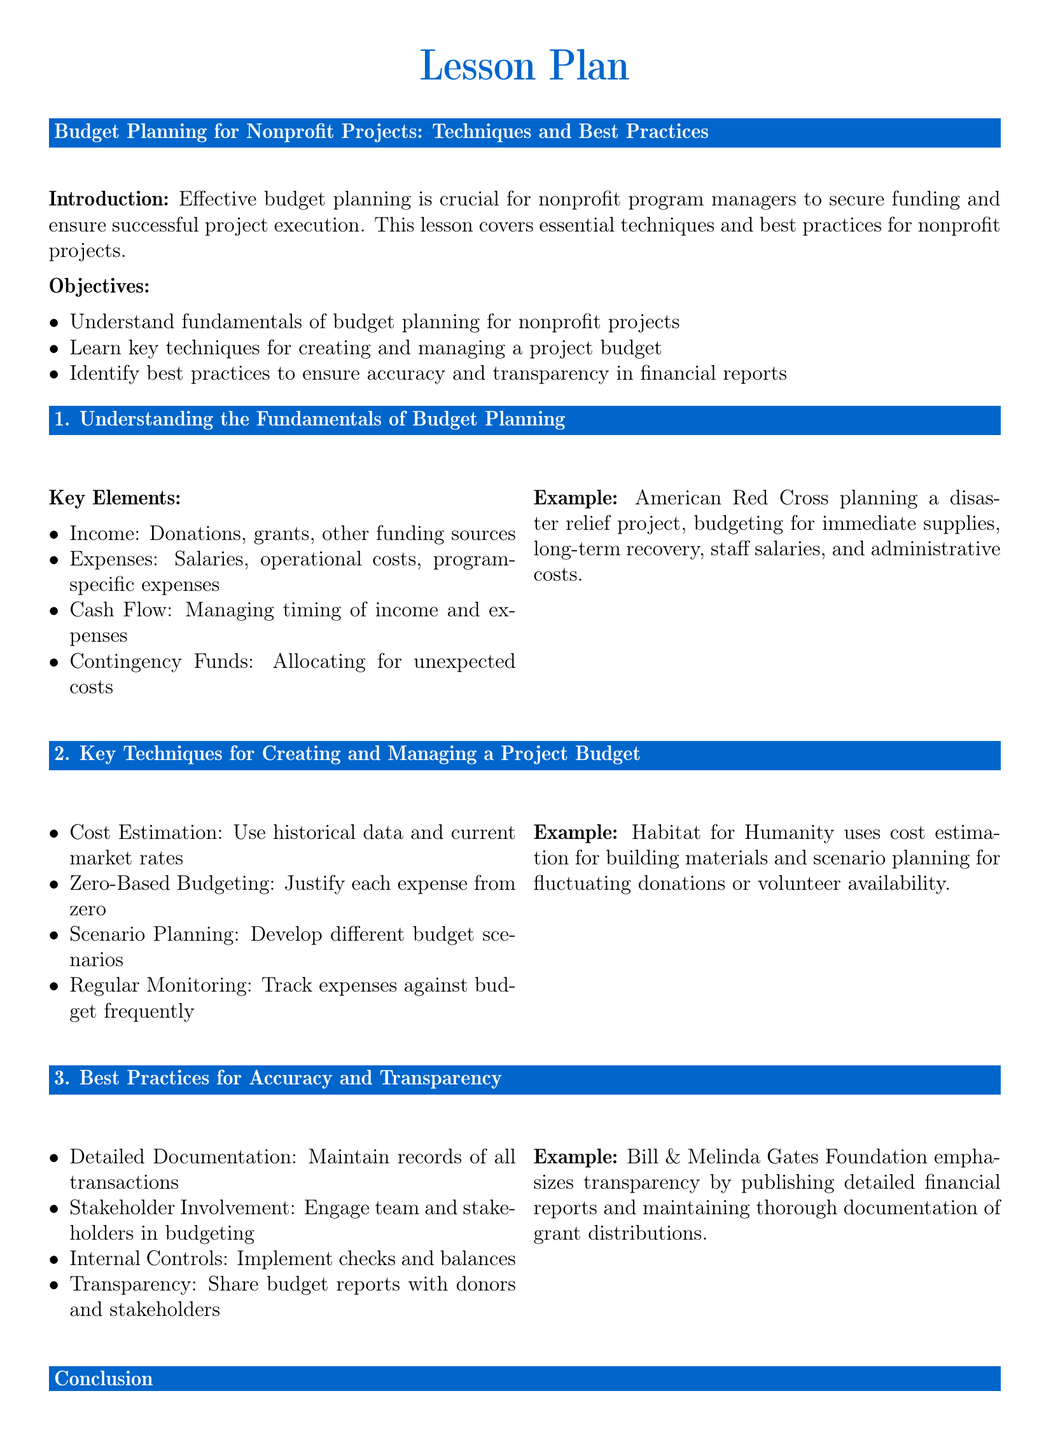What are the key elements of budget planning? The document lists key elements such as Income, Expenses, Cash Flow, and Contingency Funds.
Answer: Income, Expenses, Cash Flow, Contingency Funds What technique involves justifying each expense from zero? The document mentions that Zero-Based Budgeting is a technique focusing on justifying each expense.
Answer: Zero-Based Budgeting Which nonprofit organization uses scenario planning for budgeting? The document provides the example of Habitat for Humanity using scenario planning for budgeting.
Answer: Habitat for Humanity What should be maintained to ensure detailed documentation? The document states that all transactions need to be recorded for detailed documentation.
Answer: Records of all transactions What is the main call to action in the conclusion? The document encourages applying budget planning concepts in the next project and conducting a budget review session.
Answer: Apply these concepts and conduct a budget review session 